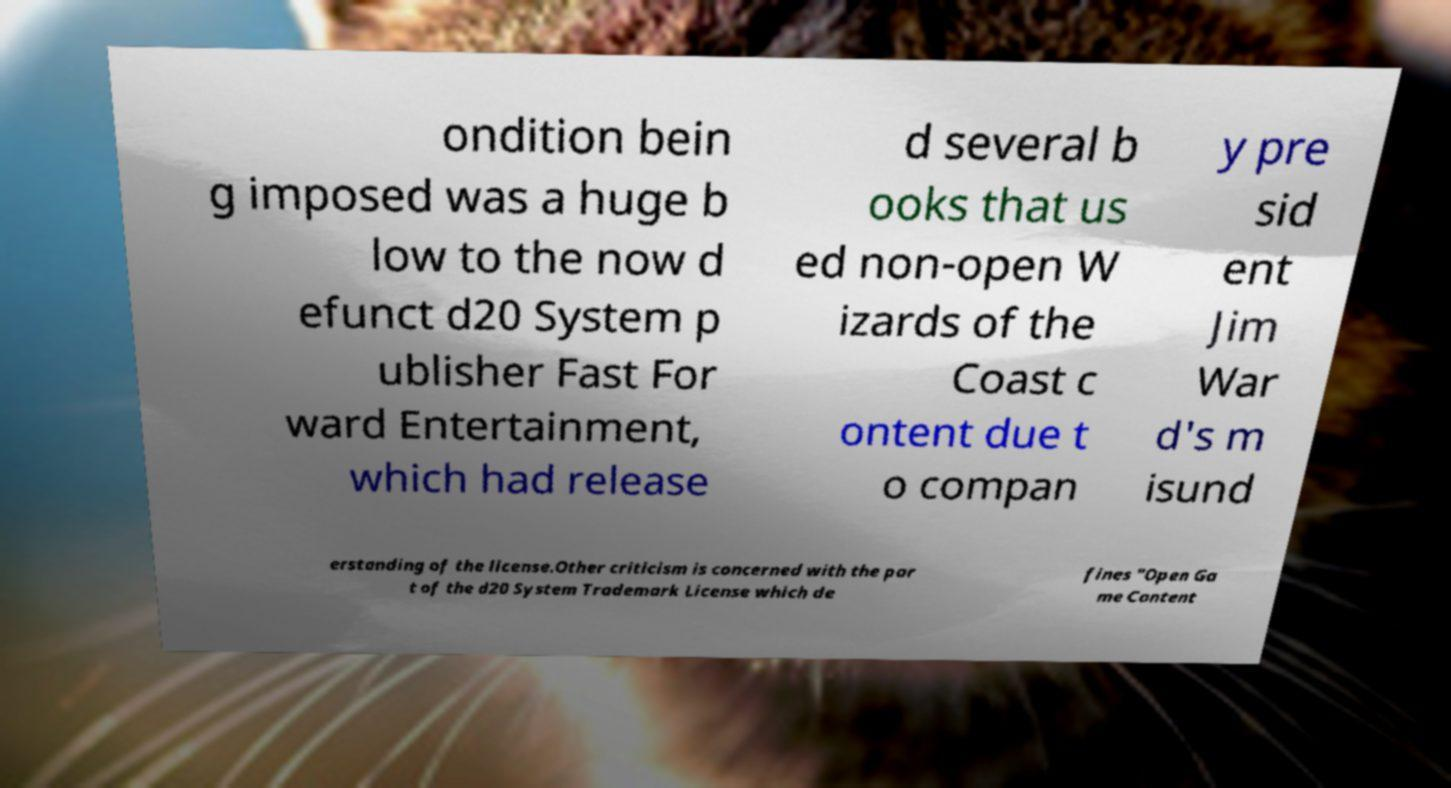There's text embedded in this image that I need extracted. Can you transcribe it verbatim? ondition bein g imposed was a huge b low to the now d efunct d20 System p ublisher Fast For ward Entertainment, which had release d several b ooks that us ed non-open W izards of the Coast c ontent due t o compan y pre sid ent Jim War d's m isund erstanding of the license.Other criticism is concerned with the par t of the d20 System Trademark License which de fines "Open Ga me Content 